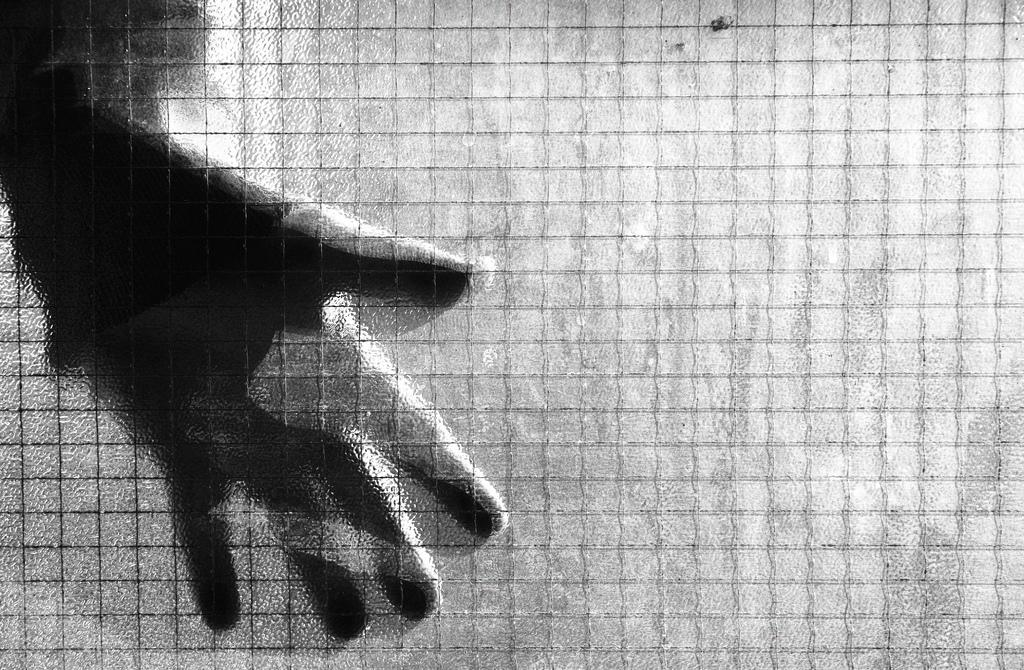What is the color scheme of the image? The image is black and white. What can be seen in the image besides the color scheme? There are hands visible in the image. What type of structure is present in the image? There is a fence in the image. Reasoning: Let's think step by following the guidelines to produce the conversation. We start by mentioning the color scheme of the image, which is black and white. Then, we identify the main subjects and objects in the image based on the provided facts. We formulate questions that focus on the location and characteristics of these subjects and objects, ensuring that each question can be answered definitively with the information given. We avoid yes/no questions and ensure that the language is simple and clear. Absurd Question/Question/Answer: How many bears can be seen in the image? There are no bears present in the image; it only features hands and a fence. What type of bean is visible in the image? There is no bean present in the image. What type of bean is visible in the image? There is no bean present in the image. --- Facts: 1. There is a person sitting on a chair in the image. 2. The person is holding a book. 3. There is a table next to the chair. 4. There is a lamp on the table. Absurd Topics: elephant, ocean, bicycle Conversation: What is the person in the image doing? The person is sitting on a chair in the image. What is the person holding in the image? The person is holding a book. What is located next to the chair in the image? There is a table next to the chair. What is on the table in the image? There is a lamp on the table. Reasoning: Let's think step by following the guidelines to produce the conversation. We start by identifying the main subject in the image, which is the person sitting on a chair. Then, we expand the conversation to include other items that are also visible, such as the book, table, and lamp. Each question is designed to elicit a specific detail about the image that is known from the provided facts. Absurd Question/Answer: Q 